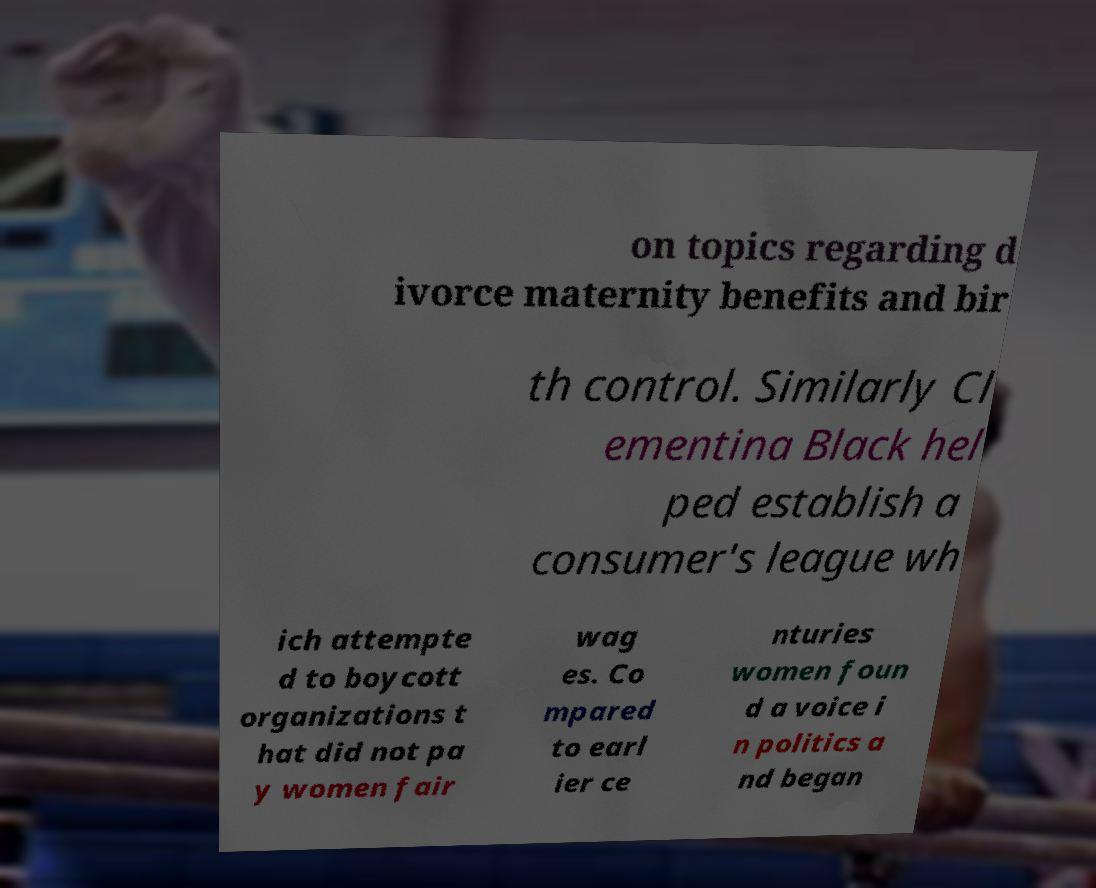For documentation purposes, I need the text within this image transcribed. Could you provide that? on topics regarding d ivorce maternity benefits and bir th control. Similarly Cl ementina Black hel ped establish a consumer's league wh ich attempte d to boycott organizations t hat did not pa y women fair wag es. Co mpared to earl ier ce nturies women foun d a voice i n politics a nd began 